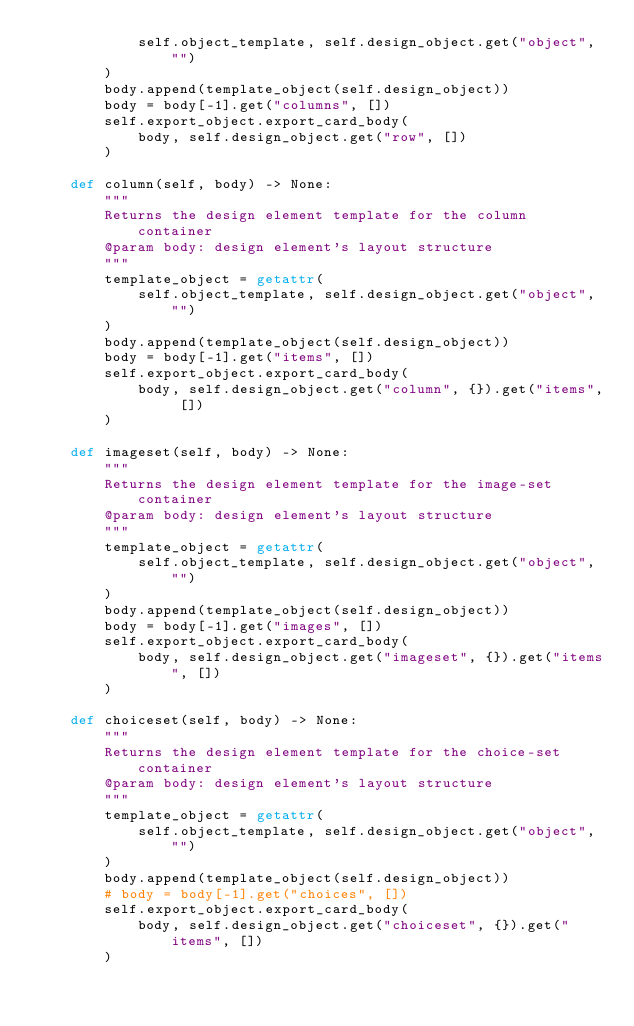Convert code to text. <code><loc_0><loc_0><loc_500><loc_500><_Python_>            self.object_template, self.design_object.get("object", "")
        )
        body.append(template_object(self.design_object))
        body = body[-1].get("columns", [])
        self.export_object.export_card_body(
            body, self.design_object.get("row", [])
        )

    def column(self, body) -> None:
        """
        Returns the design element template for the column container
        @param body: design element's layout structure
        """
        template_object = getattr(
            self.object_template, self.design_object.get("object", "")
        )
        body.append(template_object(self.design_object))
        body = body[-1].get("items", [])
        self.export_object.export_card_body(
            body, self.design_object.get("column", {}).get("items", [])
        )

    def imageset(self, body) -> None:
        """
        Returns the design element template for the image-set container
        @param body: design element's layout structure
        """
        template_object = getattr(
            self.object_template, self.design_object.get("object", "")
        )
        body.append(template_object(self.design_object))
        body = body[-1].get("images", [])
        self.export_object.export_card_body(
            body, self.design_object.get("imageset", {}).get("items", [])
        )

    def choiceset(self, body) -> None:
        """
        Returns the design element template for the choice-set container
        @param body: design element's layout structure
        """
        template_object = getattr(
            self.object_template, self.design_object.get("object", "")
        )
        body.append(template_object(self.design_object))
        # body = body[-1].get("choices", [])
        self.export_object.export_card_body(
            body, self.design_object.get("choiceset", {}).get("items", [])
        )
</code> 